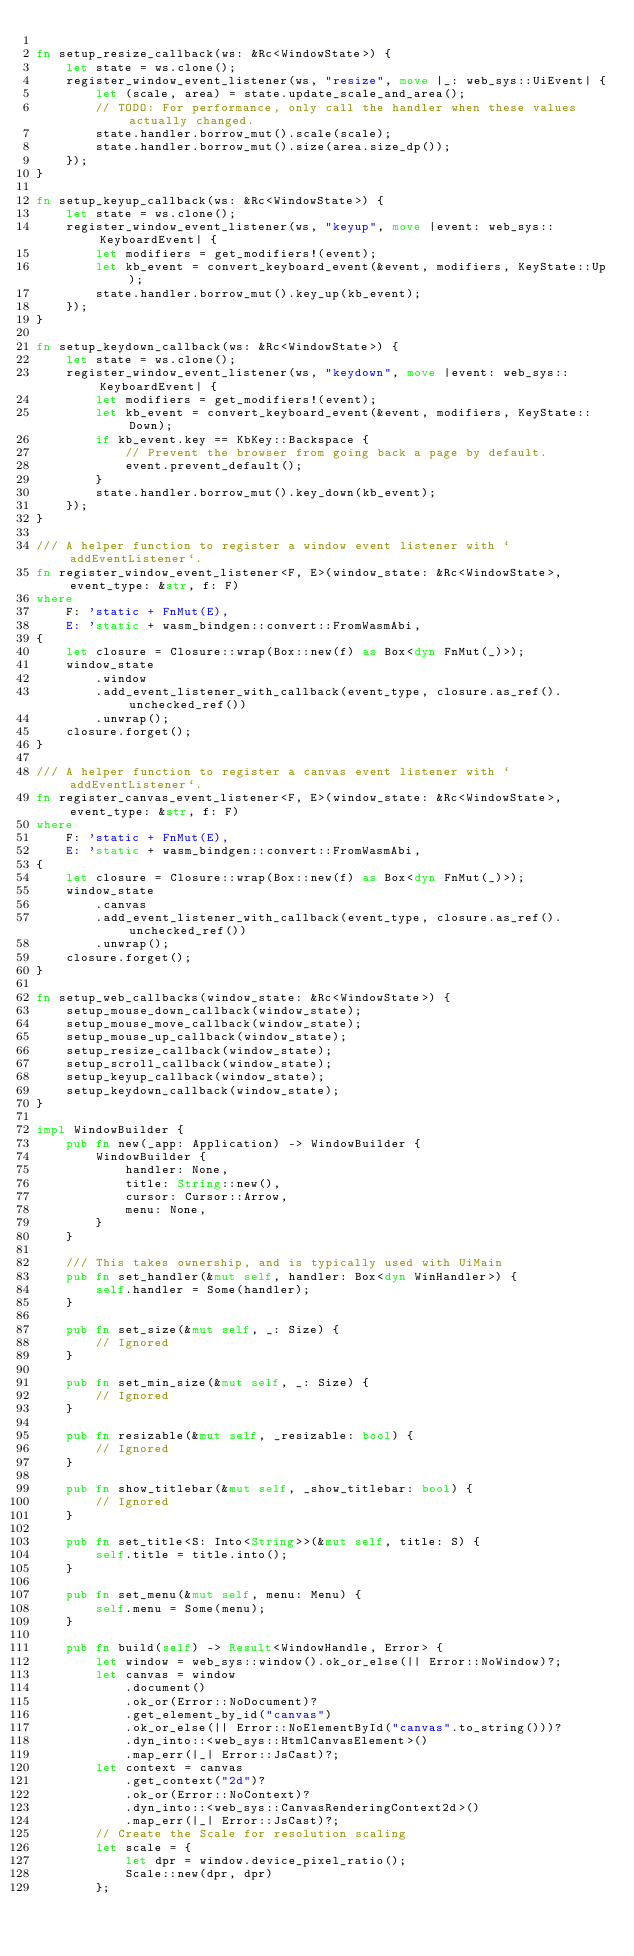<code> <loc_0><loc_0><loc_500><loc_500><_Rust_>
fn setup_resize_callback(ws: &Rc<WindowState>) {
    let state = ws.clone();
    register_window_event_listener(ws, "resize", move |_: web_sys::UiEvent| {
        let (scale, area) = state.update_scale_and_area();
        // TODO: For performance, only call the handler when these values actually changed.
        state.handler.borrow_mut().scale(scale);
        state.handler.borrow_mut().size(area.size_dp());
    });
}

fn setup_keyup_callback(ws: &Rc<WindowState>) {
    let state = ws.clone();
    register_window_event_listener(ws, "keyup", move |event: web_sys::KeyboardEvent| {
        let modifiers = get_modifiers!(event);
        let kb_event = convert_keyboard_event(&event, modifiers, KeyState::Up);
        state.handler.borrow_mut().key_up(kb_event);
    });
}

fn setup_keydown_callback(ws: &Rc<WindowState>) {
    let state = ws.clone();
    register_window_event_listener(ws, "keydown", move |event: web_sys::KeyboardEvent| {
        let modifiers = get_modifiers!(event);
        let kb_event = convert_keyboard_event(&event, modifiers, KeyState::Down);
        if kb_event.key == KbKey::Backspace {
            // Prevent the browser from going back a page by default.
            event.prevent_default();
        }
        state.handler.borrow_mut().key_down(kb_event);
    });
}

/// A helper function to register a window event listener with `addEventListener`.
fn register_window_event_listener<F, E>(window_state: &Rc<WindowState>, event_type: &str, f: F)
where
    F: 'static + FnMut(E),
    E: 'static + wasm_bindgen::convert::FromWasmAbi,
{
    let closure = Closure::wrap(Box::new(f) as Box<dyn FnMut(_)>);
    window_state
        .window
        .add_event_listener_with_callback(event_type, closure.as_ref().unchecked_ref())
        .unwrap();
    closure.forget();
}

/// A helper function to register a canvas event listener with `addEventListener`.
fn register_canvas_event_listener<F, E>(window_state: &Rc<WindowState>, event_type: &str, f: F)
where
    F: 'static + FnMut(E),
    E: 'static + wasm_bindgen::convert::FromWasmAbi,
{
    let closure = Closure::wrap(Box::new(f) as Box<dyn FnMut(_)>);
    window_state
        .canvas
        .add_event_listener_with_callback(event_type, closure.as_ref().unchecked_ref())
        .unwrap();
    closure.forget();
}

fn setup_web_callbacks(window_state: &Rc<WindowState>) {
    setup_mouse_down_callback(window_state);
    setup_mouse_move_callback(window_state);
    setup_mouse_up_callback(window_state);
    setup_resize_callback(window_state);
    setup_scroll_callback(window_state);
    setup_keyup_callback(window_state);
    setup_keydown_callback(window_state);
}

impl WindowBuilder {
    pub fn new(_app: Application) -> WindowBuilder {
        WindowBuilder {
            handler: None,
            title: String::new(),
            cursor: Cursor::Arrow,
            menu: None,
        }
    }

    /// This takes ownership, and is typically used with UiMain
    pub fn set_handler(&mut self, handler: Box<dyn WinHandler>) {
        self.handler = Some(handler);
    }

    pub fn set_size(&mut self, _: Size) {
        // Ignored
    }

    pub fn set_min_size(&mut self, _: Size) {
        // Ignored
    }

    pub fn resizable(&mut self, _resizable: bool) {
        // Ignored
    }

    pub fn show_titlebar(&mut self, _show_titlebar: bool) {
        // Ignored
    }

    pub fn set_title<S: Into<String>>(&mut self, title: S) {
        self.title = title.into();
    }

    pub fn set_menu(&mut self, menu: Menu) {
        self.menu = Some(menu);
    }

    pub fn build(self) -> Result<WindowHandle, Error> {
        let window = web_sys::window().ok_or_else(|| Error::NoWindow)?;
        let canvas = window
            .document()
            .ok_or(Error::NoDocument)?
            .get_element_by_id("canvas")
            .ok_or_else(|| Error::NoElementById("canvas".to_string()))?
            .dyn_into::<web_sys::HtmlCanvasElement>()
            .map_err(|_| Error::JsCast)?;
        let context = canvas
            .get_context("2d")?
            .ok_or(Error::NoContext)?
            .dyn_into::<web_sys::CanvasRenderingContext2d>()
            .map_err(|_| Error::JsCast)?;
        // Create the Scale for resolution scaling
        let scale = {
            let dpr = window.device_pixel_ratio();
            Scale::new(dpr, dpr)
        };</code> 